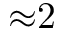Convert formula to latex. <formula><loc_0><loc_0><loc_500><loc_500>{ \approx } 2</formula> 